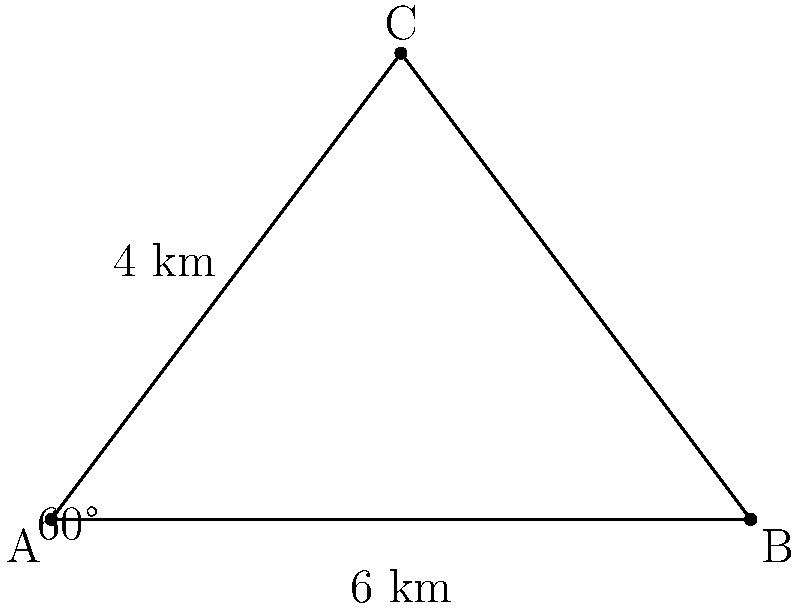As part of a sustainable agriculture initiative, you're designing an irrigation system for a triangular field. The field has sides of 6 km and 4 km, with an angle of 60° between them. What is the length of the third side of the field to the nearest 0.1 km? This information will help determine the optimal layout for the irrigation system. To solve this problem, we'll use the law of cosines. Here's the step-by-step solution:

1) Let's denote the unknown side as $c$, and the known sides as $a = 6$ km and $b = 4$ km.

2) The law of cosines states: $c^2 = a^2 + b^2 - 2ab \cos(C)$

3) We know that $C = 60°$, so $\cos(C) = \cos(60°) = \frac{1}{2}$

4) Substituting the values:

   $c^2 = 6^2 + 4^2 - 2(6)(4) \cos(60°)$

5) Simplify:
   
   $c^2 = 36 + 16 - 2(24)(\frac{1}{2})$
   $c^2 = 36 + 16 - 24$
   $c^2 = 28$

6) Take the square root of both sides:

   $c = \sqrt{28}$

7) Simplify:
   
   $c = 2\sqrt{7} \approx 5.29$ km

8) Rounding to the nearest 0.1 km:

   $c \approx 5.3$ km
Answer: 5.3 km 